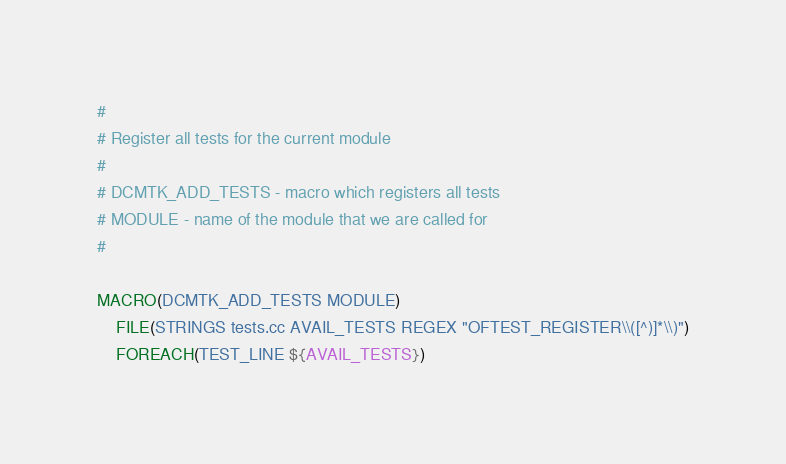<code> <loc_0><loc_0><loc_500><loc_500><_CMake_>#
# Register all tests for the current module
#
# DCMTK_ADD_TESTS - macro which registers all tests
# MODULE - name of the module that we are called for
#

MACRO(DCMTK_ADD_TESTS MODULE)
    FILE(STRINGS tests.cc AVAIL_TESTS REGEX "OFTEST_REGISTER\\([^)]*\\)")
    FOREACH(TEST_LINE ${AVAIL_TESTS})</code> 